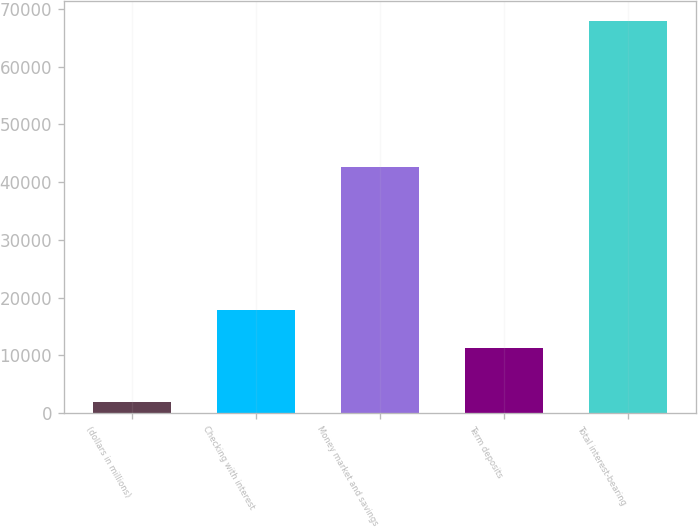Convert chart to OTSL. <chart><loc_0><loc_0><loc_500><loc_500><bar_chart><fcel>(dollars in millions)<fcel>Checking with interest<fcel>Money market and savings<fcel>Term deposits<fcel>Total interest-bearing<nl><fcel>2013<fcel>17858.4<fcel>42575<fcel>11266<fcel>67937<nl></chart> 